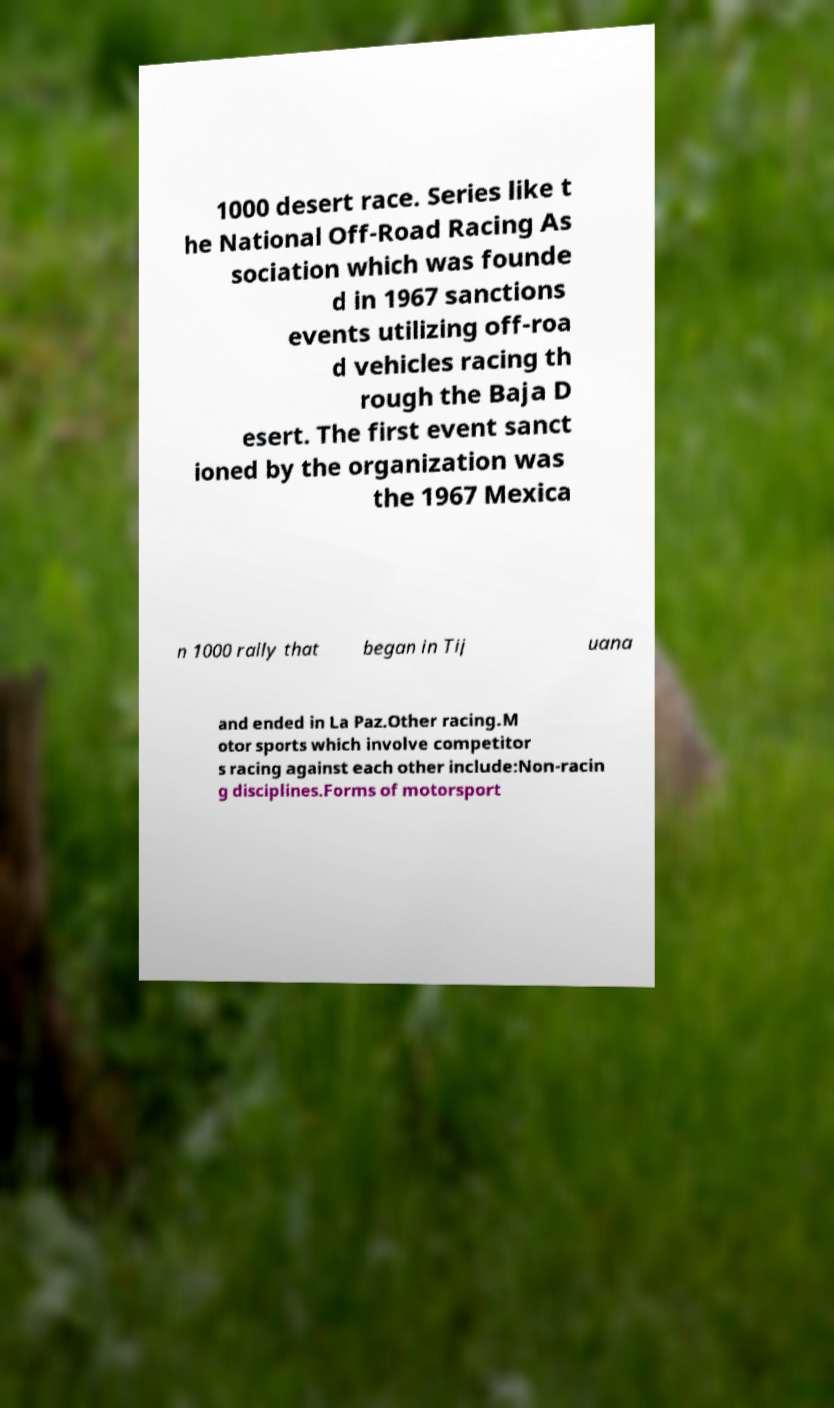Please identify and transcribe the text found in this image. 1000 desert race. Series like t he National Off-Road Racing As sociation which was founde d in 1967 sanctions events utilizing off-roa d vehicles racing th rough the Baja D esert. The first event sanct ioned by the organization was the 1967 Mexica n 1000 rally that began in Tij uana and ended in La Paz.Other racing.M otor sports which involve competitor s racing against each other include:Non-racin g disciplines.Forms of motorsport 